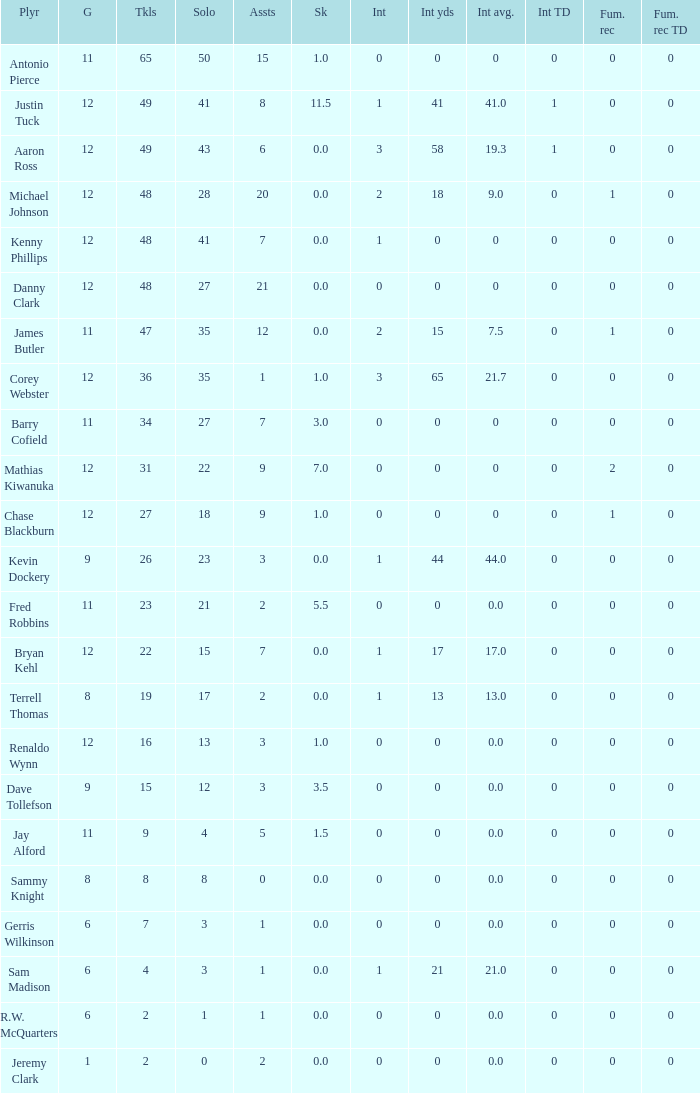Name the least fum rec td 0.0. 